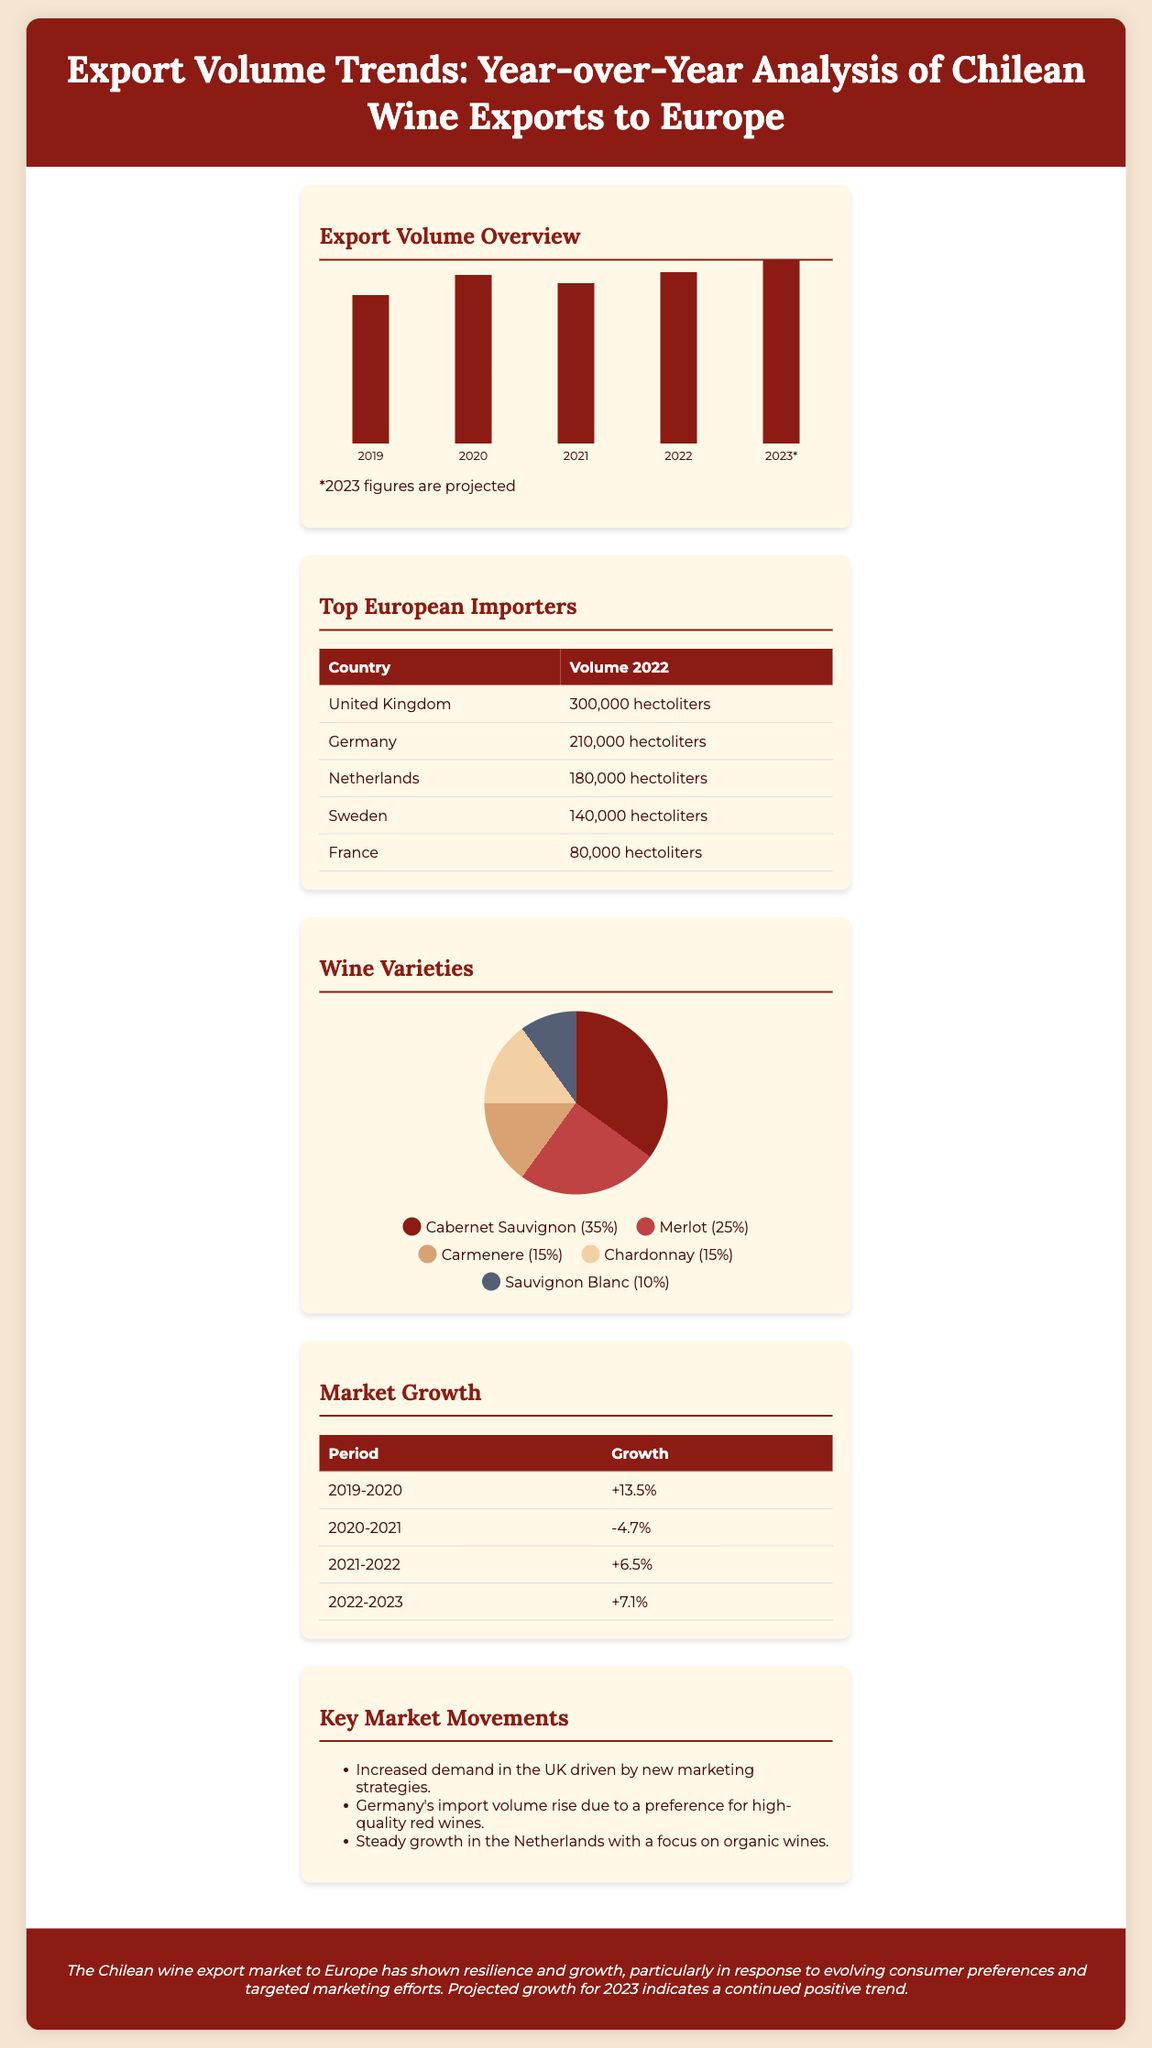What was the export volume in 2022? The export volume for 2022 is displayed in the chart and is represented by the bar labeled 2022, which has a height of 187 pixels corresponding to the given value.
Answer: 187 Which country was the top importer of Chilean wine in 2022? The table shows the countries listed in order of volume, with the United Kingdom at the top.
Answer: United Kingdom What was the growth percentage from 2020 to 2021? The growth table shows the percentage change, which is indicated by the row for the period 2020-2021.
Answer: -4.7% What percentage of the wine exports was Cabernet Sauvignon? The pie chart legend specifies the percentage of each wine variety, with Cabernet Sauvignon noted as the largest segment.
Answer: 35% What projected export volume does Chilean wine expect for 2023? The document indicates that the figures for 2023 are projected and corresponds to the bar labeled 2023.
Answer: 200 How much wine did Germany import in 2022? The table for top European importers specifies the volume specifically for Germany.
Answer: 210,000 hectoliters What was a significant market trend observed in the UK? The bullet points under Key Market Movements detail the increasing demand in the UK and the driving factor.
Answer: New marketing strategies What was the volume of Carmenere in the wine variety distribution? The pie chart provides the proportional breakdown, showing Carmenere's specific percentage amount.
Answer: 15% What was the average growth rate from 2021 to 2023? The growth rates from 2022 to 2023 are compared for determining the average growth across these years using their respective percentages.
Answer: Approximately 7% 